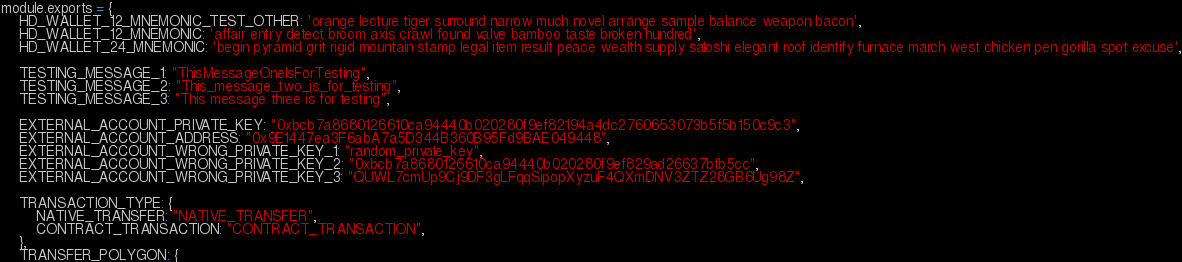<code> <loc_0><loc_0><loc_500><loc_500><_JavaScript_>module.exports = {
    HD_WALLET_12_MNEMONIC_TEST_OTHER: 'orange lecture tiger surround narrow much novel arrange sample balance weapon bacon',
    HD_WALLET_12_MNEMONIC: 'affair entry detect broom axis crawl found valve bamboo taste broken hundred',
    HD_WALLET_24_MNEMONIC: 'begin pyramid grit rigid mountain stamp legal item result peace wealth supply satoshi elegant roof identify furnace march west chicken pen gorilla spot excuse',

    TESTING_MESSAGE_1: "ThisMessageOneIsForTesting",
    TESTING_MESSAGE_2: "This_message_two_is_for_testing",
    TESTING_MESSAGE_3: "This message three is for testing",

    EXTERNAL_ACCOUNT_PRIVATE_KEY: "0xbcb7a8680126610ca94440b020280f9ef82194a4dc2760653073b5f5b150c9c3",
    EXTERNAL_ACCOUNT_ADDRESS: "0x9E1447ea3F6abA7a5D344B360B95Fd9BAE049448",
    EXTERNAL_ACCOUNT_WRONG_PRIVATE_KEY_1: "random_private_key",
    EXTERNAL_ACCOUNT_WRONG_PRIVATE_KEY_2: "0xbcb7a8680126610ca94440b020280f9ef829ad26637bfb5cc",
    EXTERNAL_ACCOUNT_WRONG_PRIVATE_KEY_3: "QUWL7cmUp9Cj9DF3gLFqqSipopXyzuF4QXmDNV3ZTZ28GB6Ug98Z",

    TRANSACTION_TYPE: {
        NATIVE_TRANSFER: "NATIVE_TRANSFER",
        CONTRACT_TRANSACTION: "CONTRACT_TRANSACTION",
    },
    TRANSFER_POLYGON: {</code> 